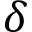<formula> <loc_0><loc_0><loc_500><loc_500>\delta</formula> 